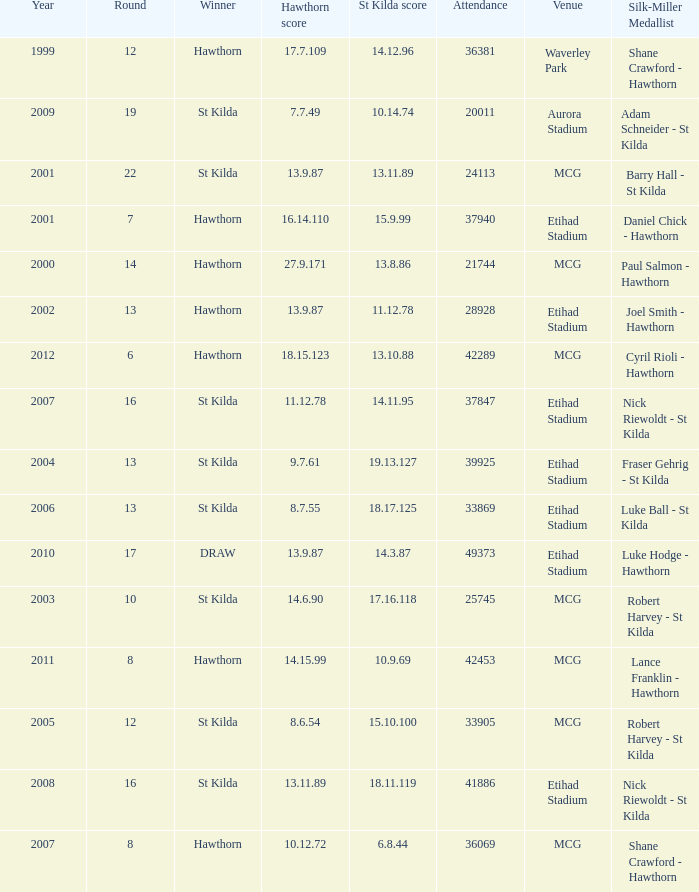Who is the winner when the st kilda score is 13.10.88? Hawthorn. 